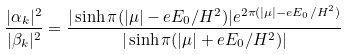Convert formula to latex. <formula><loc_0><loc_0><loc_500><loc_500>\frac { | \alpha _ { k } | ^ { 2 } } { | \beta _ { k } | ^ { 2 } } = \frac { | \sinh \pi ( | \mu | - e E _ { 0 } / H ^ { 2 } ) | e ^ { 2 \pi ( | \mu | - e E _ { 0 } / H ^ { 2 } ) } } { | \sinh \pi ( | \mu | + e E _ { 0 } / H ^ { 2 } ) | }</formula> 